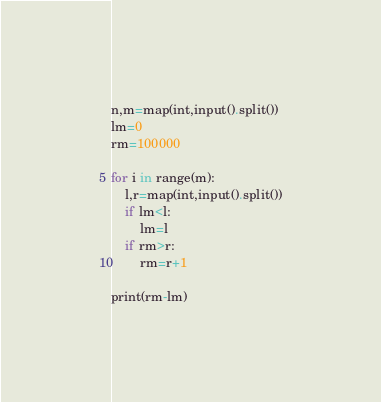Convert code to text. <code><loc_0><loc_0><loc_500><loc_500><_Python_>n,m=map(int,input().split())
lm=0
rm=100000

for i in range(m):
    l,r=map(int,input().split())
    if lm<l:
        lm=l
    if rm>r:
        rm=r+1

print(rm-lm)
</code> 